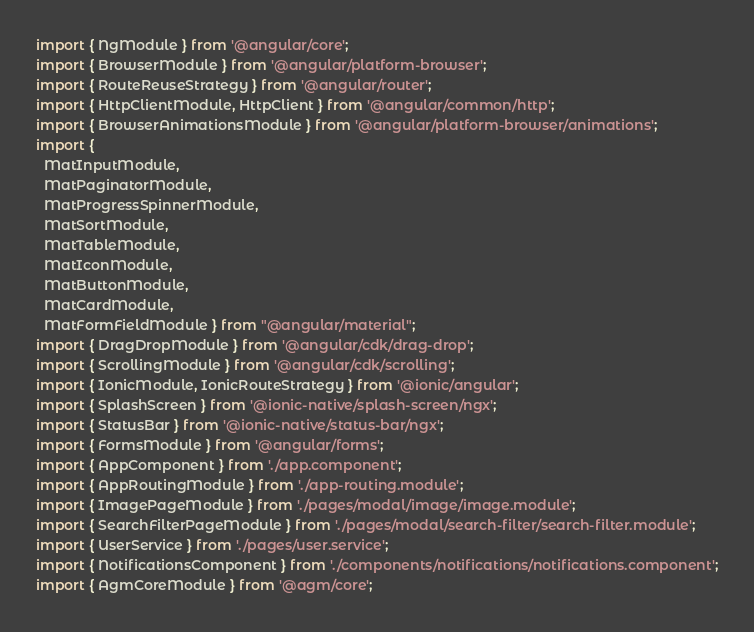<code> <loc_0><loc_0><loc_500><loc_500><_TypeScript_>import { NgModule } from '@angular/core';
import { BrowserModule } from '@angular/platform-browser';
import { RouteReuseStrategy } from '@angular/router';
import { HttpClientModule, HttpClient } from '@angular/common/http';
import { BrowserAnimationsModule } from '@angular/platform-browser/animations';
import {
  MatInputModule,
  MatPaginatorModule,
  MatProgressSpinnerModule,
  MatSortModule,
  MatTableModule,
  MatIconModule,
  MatButtonModule,
  MatCardModule,
  MatFormFieldModule } from "@angular/material";
import { DragDropModule } from '@angular/cdk/drag-drop';
import { ScrollingModule } from '@angular/cdk/scrolling';
import { IonicModule, IonicRouteStrategy } from '@ionic/angular';
import { SplashScreen } from '@ionic-native/splash-screen/ngx';
import { StatusBar } from '@ionic-native/status-bar/ngx';
import { FormsModule } from '@angular/forms';
import { AppComponent } from './app.component';
import { AppRoutingModule } from './app-routing.module';
import { ImagePageModule } from './pages/modal/image/image.module';
import { SearchFilterPageModule } from './pages/modal/search-filter/search-filter.module';
import { UserService } from './pages/user.service';
import { NotificationsComponent } from './components/notifications/notifications.component';
import { AgmCoreModule } from '@agm/core'; </code> 